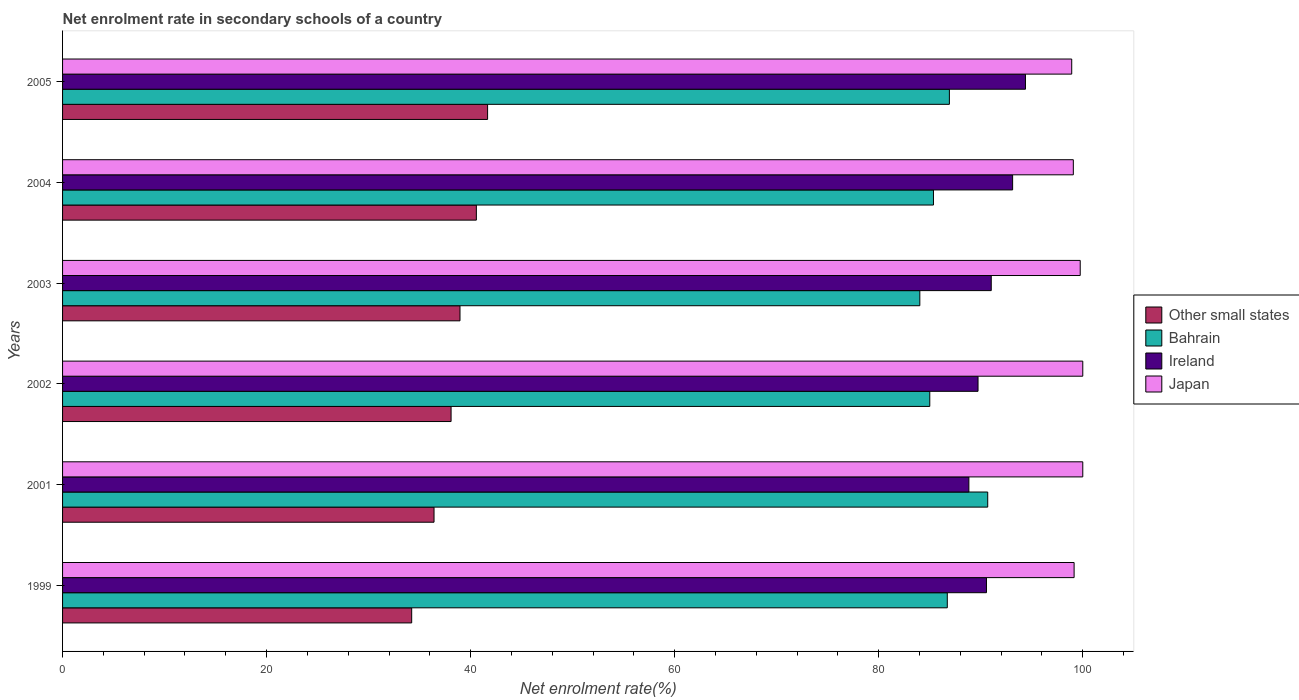How many groups of bars are there?
Your response must be concise. 6. How many bars are there on the 2nd tick from the top?
Make the answer very short. 4. How many bars are there on the 2nd tick from the bottom?
Give a very brief answer. 4. What is the label of the 1st group of bars from the top?
Ensure brevity in your answer.  2005. What is the net enrolment rate in secondary schools in Bahrain in 2004?
Make the answer very short. 85.36. Across all years, what is the minimum net enrolment rate in secondary schools in Ireland?
Give a very brief answer. 88.83. In which year was the net enrolment rate in secondary schools in Ireland maximum?
Your answer should be compact. 2005. What is the total net enrolment rate in secondary schools in Bahrain in the graph?
Keep it short and to the point. 518.72. What is the difference between the net enrolment rate in secondary schools in Ireland in 2001 and that in 2005?
Keep it short and to the point. -5.55. What is the difference between the net enrolment rate in secondary schools in Bahrain in 2005 and the net enrolment rate in secondary schools in Ireland in 2001?
Offer a very short reply. -1.91. What is the average net enrolment rate in secondary schools in Ireland per year?
Provide a succinct answer. 91.28. In the year 2004, what is the difference between the net enrolment rate in secondary schools in Other small states and net enrolment rate in secondary schools in Japan?
Provide a succinct answer. -58.51. What is the ratio of the net enrolment rate in secondary schools in Other small states in 2001 to that in 2002?
Keep it short and to the point. 0.96. Is the net enrolment rate in secondary schools in Japan in 2001 less than that in 2002?
Make the answer very short. No. Is the difference between the net enrolment rate in secondary schools in Other small states in 2004 and 2005 greater than the difference between the net enrolment rate in secondary schools in Japan in 2004 and 2005?
Give a very brief answer. No. What is the difference between the highest and the second highest net enrolment rate in secondary schools in Other small states?
Offer a very short reply. 1.1. What is the difference between the highest and the lowest net enrolment rate in secondary schools in Japan?
Your response must be concise. 1.08. Is the sum of the net enrolment rate in secondary schools in Bahrain in 2002 and 2003 greater than the maximum net enrolment rate in secondary schools in Japan across all years?
Offer a very short reply. Yes. What does the 2nd bar from the top in 2002 represents?
Make the answer very short. Ireland. What does the 3rd bar from the bottom in 2005 represents?
Keep it short and to the point. Ireland. Is it the case that in every year, the sum of the net enrolment rate in secondary schools in Other small states and net enrolment rate in secondary schools in Ireland is greater than the net enrolment rate in secondary schools in Japan?
Make the answer very short. Yes. Are all the bars in the graph horizontal?
Offer a terse response. Yes. How many years are there in the graph?
Make the answer very short. 6. How are the legend labels stacked?
Keep it short and to the point. Vertical. What is the title of the graph?
Your answer should be very brief. Net enrolment rate in secondary schools of a country. What is the label or title of the X-axis?
Your response must be concise. Net enrolment rate(%). What is the Net enrolment rate(%) in Other small states in 1999?
Your answer should be compact. 34.22. What is the Net enrolment rate(%) of Bahrain in 1999?
Offer a very short reply. 86.72. What is the Net enrolment rate(%) in Ireland in 1999?
Your answer should be very brief. 90.56. What is the Net enrolment rate(%) of Japan in 1999?
Offer a very short reply. 99.15. What is the Net enrolment rate(%) in Other small states in 2001?
Offer a very short reply. 36.41. What is the Net enrolment rate(%) of Bahrain in 2001?
Make the answer very short. 90.68. What is the Net enrolment rate(%) of Ireland in 2001?
Provide a succinct answer. 88.83. What is the Net enrolment rate(%) in Japan in 2001?
Your answer should be very brief. 100. What is the Net enrolment rate(%) of Other small states in 2002?
Your response must be concise. 38.08. What is the Net enrolment rate(%) of Bahrain in 2002?
Your answer should be compact. 85. What is the Net enrolment rate(%) of Ireland in 2002?
Provide a short and direct response. 89.73. What is the Net enrolment rate(%) of Japan in 2002?
Provide a short and direct response. 100. What is the Net enrolment rate(%) in Other small states in 2003?
Provide a succinct answer. 38.96. What is the Net enrolment rate(%) of Bahrain in 2003?
Your answer should be compact. 84.03. What is the Net enrolment rate(%) in Ireland in 2003?
Give a very brief answer. 91.03. What is the Net enrolment rate(%) in Japan in 2003?
Offer a very short reply. 99.75. What is the Net enrolment rate(%) of Other small states in 2004?
Your answer should be very brief. 40.56. What is the Net enrolment rate(%) of Bahrain in 2004?
Offer a very short reply. 85.36. What is the Net enrolment rate(%) of Ireland in 2004?
Make the answer very short. 93.12. What is the Net enrolment rate(%) in Japan in 2004?
Make the answer very short. 99.07. What is the Net enrolment rate(%) in Other small states in 2005?
Give a very brief answer. 41.66. What is the Net enrolment rate(%) of Bahrain in 2005?
Provide a succinct answer. 86.93. What is the Net enrolment rate(%) in Ireland in 2005?
Provide a succinct answer. 94.38. What is the Net enrolment rate(%) of Japan in 2005?
Your answer should be compact. 98.92. Across all years, what is the maximum Net enrolment rate(%) of Other small states?
Ensure brevity in your answer.  41.66. Across all years, what is the maximum Net enrolment rate(%) in Bahrain?
Provide a succinct answer. 90.68. Across all years, what is the maximum Net enrolment rate(%) in Ireland?
Make the answer very short. 94.38. Across all years, what is the maximum Net enrolment rate(%) of Japan?
Offer a very short reply. 100. Across all years, what is the minimum Net enrolment rate(%) of Other small states?
Make the answer very short. 34.22. Across all years, what is the minimum Net enrolment rate(%) of Bahrain?
Your response must be concise. 84.03. Across all years, what is the minimum Net enrolment rate(%) in Ireland?
Your response must be concise. 88.83. Across all years, what is the minimum Net enrolment rate(%) of Japan?
Offer a terse response. 98.92. What is the total Net enrolment rate(%) of Other small states in the graph?
Offer a very short reply. 229.89. What is the total Net enrolment rate(%) in Bahrain in the graph?
Provide a short and direct response. 518.72. What is the total Net enrolment rate(%) of Ireland in the graph?
Provide a succinct answer. 547.66. What is the total Net enrolment rate(%) of Japan in the graph?
Offer a terse response. 596.89. What is the difference between the Net enrolment rate(%) of Other small states in 1999 and that in 2001?
Provide a short and direct response. -2.19. What is the difference between the Net enrolment rate(%) of Bahrain in 1999 and that in 2001?
Your response must be concise. -3.96. What is the difference between the Net enrolment rate(%) of Ireland in 1999 and that in 2001?
Your answer should be very brief. 1.73. What is the difference between the Net enrolment rate(%) of Japan in 1999 and that in 2001?
Your response must be concise. -0.85. What is the difference between the Net enrolment rate(%) in Other small states in 1999 and that in 2002?
Provide a short and direct response. -3.86. What is the difference between the Net enrolment rate(%) in Bahrain in 1999 and that in 2002?
Ensure brevity in your answer.  1.72. What is the difference between the Net enrolment rate(%) of Ireland in 1999 and that in 2002?
Your answer should be compact. 0.83. What is the difference between the Net enrolment rate(%) in Japan in 1999 and that in 2002?
Give a very brief answer. -0.85. What is the difference between the Net enrolment rate(%) in Other small states in 1999 and that in 2003?
Offer a terse response. -4.74. What is the difference between the Net enrolment rate(%) of Bahrain in 1999 and that in 2003?
Offer a very short reply. 2.69. What is the difference between the Net enrolment rate(%) in Ireland in 1999 and that in 2003?
Provide a short and direct response. -0.47. What is the difference between the Net enrolment rate(%) of Japan in 1999 and that in 2003?
Your response must be concise. -0.6. What is the difference between the Net enrolment rate(%) in Other small states in 1999 and that in 2004?
Provide a short and direct response. -6.34. What is the difference between the Net enrolment rate(%) of Bahrain in 1999 and that in 2004?
Give a very brief answer. 1.36. What is the difference between the Net enrolment rate(%) in Ireland in 1999 and that in 2004?
Offer a terse response. -2.56. What is the difference between the Net enrolment rate(%) of Japan in 1999 and that in 2004?
Provide a succinct answer. 0.08. What is the difference between the Net enrolment rate(%) of Other small states in 1999 and that in 2005?
Provide a short and direct response. -7.44. What is the difference between the Net enrolment rate(%) of Bahrain in 1999 and that in 2005?
Offer a terse response. -0.2. What is the difference between the Net enrolment rate(%) of Ireland in 1999 and that in 2005?
Offer a very short reply. -3.82. What is the difference between the Net enrolment rate(%) of Japan in 1999 and that in 2005?
Offer a very short reply. 0.23. What is the difference between the Net enrolment rate(%) of Other small states in 2001 and that in 2002?
Your answer should be very brief. -1.67. What is the difference between the Net enrolment rate(%) in Bahrain in 2001 and that in 2002?
Keep it short and to the point. 5.68. What is the difference between the Net enrolment rate(%) of Ireland in 2001 and that in 2002?
Your response must be concise. -0.9. What is the difference between the Net enrolment rate(%) in Other small states in 2001 and that in 2003?
Provide a short and direct response. -2.54. What is the difference between the Net enrolment rate(%) in Bahrain in 2001 and that in 2003?
Offer a very short reply. 6.66. What is the difference between the Net enrolment rate(%) in Ireland in 2001 and that in 2003?
Provide a succinct answer. -2.19. What is the difference between the Net enrolment rate(%) in Japan in 2001 and that in 2003?
Offer a very short reply. 0.25. What is the difference between the Net enrolment rate(%) in Other small states in 2001 and that in 2004?
Give a very brief answer. -4.15. What is the difference between the Net enrolment rate(%) of Bahrain in 2001 and that in 2004?
Give a very brief answer. 5.32. What is the difference between the Net enrolment rate(%) in Ireland in 2001 and that in 2004?
Make the answer very short. -4.29. What is the difference between the Net enrolment rate(%) in Japan in 2001 and that in 2004?
Offer a very short reply. 0.93. What is the difference between the Net enrolment rate(%) of Other small states in 2001 and that in 2005?
Your answer should be very brief. -5.25. What is the difference between the Net enrolment rate(%) of Bahrain in 2001 and that in 2005?
Provide a succinct answer. 3.76. What is the difference between the Net enrolment rate(%) in Ireland in 2001 and that in 2005?
Make the answer very short. -5.55. What is the difference between the Net enrolment rate(%) in Japan in 2001 and that in 2005?
Provide a short and direct response. 1.08. What is the difference between the Net enrolment rate(%) in Other small states in 2002 and that in 2003?
Offer a very short reply. -0.87. What is the difference between the Net enrolment rate(%) in Bahrain in 2002 and that in 2003?
Make the answer very short. 0.98. What is the difference between the Net enrolment rate(%) of Ireland in 2002 and that in 2003?
Ensure brevity in your answer.  -1.29. What is the difference between the Net enrolment rate(%) in Japan in 2002 and that in 2003?
Your answer should be compact. 0.25. What is the difference between the Net enrolment rate(%) in Other small states in 2002 and that in 2004?
Provide a succinct answer. -2.48. What is the difference between the Net enrolment rate(%) in Bahrain in 2002 and that in 2004?
Keep it short and to the point. -0.36. What is the difference between the Net enrolment rate(%) of Ireland in 2002 and that in 2004?
Keep it short and to the point. -3.39. What is the difference between the Net enrolment rate(%) in Japan in 2002 and that in 2004?
Your answer should be compact. 0.93. What is the difference between the Net enrolment rate(%) in Other small states in 2002 and that in 2005?
Give a very brief answer. -3.58. What is the difference between the Net enrolment rate(%) in Bahrain in 2002 and that in 2005?
Keep it short and to the point. -1.92. What is the difference between the Net enrolment rate(%) in Ireland in 2002 and that in 2005?
Offer a terse response. -4.65. What is the difference between the Net enrolment rate(%) of Japan in 2002 and that in 2005?
Your response must be concise. 1.08. What is the difference between the Net enrolment rate(%) of Other small states in 2003 and that in 2004?
Offer a terse response. -1.6. What is the difference between the Net enrolment rate(%) of Bahrain in 2003 and that in 2004?
Offer a very short reply. -1.34. What is the difference between the Net enrolment rate(%) in Ireland in 2003 and that in 2004?
Ensure brevity in your answer.  -2.1. What is the difference between the Net enrolment rate(%) in Japan in 2003 and that in 2004?
Provide a succinct answer. 0.68. What is the difference between the Net enrolment rate(%) in Other small states in 2003 and that in 2005?
Offer a terse response. -2.7. What is the difference between the Net enrolment rate(%) in Bahrain in 2003 and that in 2005?
Make the answer very short. -2.9. What is the difference between the Net enrolment rate(%) in Ireland in 2003 and that in 2005?
Keep it short and to the point. -3.35. What is the difference between the Net enrolment rate(%) in Japan in 2003 and that in 2005?
Your answer should be compact. 0.83. What is the difference between the Net enrolment rate(%) in Other small states in 2004 and that in 2005?
Give a very brief answer. -1.1. What is the difference between the Net enrolment rate(%) of Bahrain in 2004 and that in 2005?
Your answer should be compact. -1.56. What is the difference between the Net enrolment rate(%) of Ireland in 2004 and that in 2005?
Your response must be concise. -1.26. What is the difference between the Net enrolment rate(%) in Japan in 2004 and that in 2005?
Provide a succinct answer. 0.16. What is the difference between the Net enrolment rate(%) in Other small states in 1999 and the Net enrolment rate(%) in Bahrain in 2001?
Your response must be concise. -56.46. What is the difference between the Net enrolment rate(%) of Other small states in 1999 and the Net enrolment rate(%) of Ireland in 2001?
Offer a very short reply. -54.61. What is the difference between the Net enrolment rate(%) in Other small states in 1999 and the Net enrolment rate(%) in Japan in 2001?
Provide a succinct answer. -65.78. What is the difference between the Net enrolment rate(%) in Bahrain in 1999 and the Net enrolment rate(%) in Ireland in 2001?
Your answer should be compact. -2.11. What is the difference between the Net enrolment rate(%) in Bahrain in 1999 and the Net enrolment rate(%) in Japan in 2001?
Offer a terse response. -13.28. What is the difference between the Net enrolment rate(%) in Ireland in 1999 and the Net enrolment rate(%) in Japan in 2001?
Ensure brevity in your answer.  -9.44. What is the difference between the Net enrolment rate(%) in Other small states in 1999 and the Net enrolment rate(%) in Bahrain in 2002?
Offer a very short reply. -50.78. What is the difference between the Net enrolment rate(%) in Other small states in 1999 and the Net enrolment rate(%) in Ireland in 2002?
Ensure brevity in your answer.  -55.51. What is the difference between the Net enrolment rate(%) in Other small states in 1999 and the Net enrolment rate(%) in Japan in 2002?
Provide a short and direct response. -65.78. What is the difference between the Net enrolment rate(%) of Bahrain in 1999 and the Net enrolment rate(%) of Ireland in 2002?
Keep it short and to the point. -3.01. What is the difference between the Net enrolment rate(%) in Bahrain in 1999 and the Net enrolment rate(%) in Japan in 2002?
Provide a succinct answer. -13.28. What is the difference between the Net enrolment rate(%) in Ireland in 1999 and the Net enrolment rate(%) in Japan in 2002?
Give a very brief answer. -9.44. What is the difference between the Net enrolment rate(%) in Other small states in 1999 and the Net enrolment rate(%) in Bahrain in 2003?
Give a very brief answer. -49.81. What is the difference between the Net enrolment rate(%) of Other small states in 1999 and the Net enrolment rate(%) of Ireland in 2003?
Offer a terse response. -56.81. What is the difference between the Net enrolment rate(%) of Other small states in 1999 and the Net enrolment rate(%) of Japan in 2003?
Provide a short and direct response. -65.53. What is the difference between the Net enrolment rate(%) in Bahrain in 1999 and the Net enrolment rate(%) in Ireland in 2003?
Make the answer very short. -4.31. What is the difference between the Net enrolment rate(%) of Bahrain in 1999 and the Net enrolment rate(%) of Japan in 2003?
Give a very brief answer. -13.03. What is the difference between the Net enrolment rate(%) in Ireland in 1999 and the Net enrolment rate(%) in Japan in 2003?
Offer a very short reply. -9.19. What is the difference between the Net enrolment rate(%) of Other small states in 1999 and the Net enrolment rate(%) of Bahrain in 2004?
Make the answer very short. -51.14. What is the difference between the Net enrolment rate(%) of Other small states in 1999 and the Net enrolment rate(%) of Ireland in 2004?
Your answer should be very brief. -58.9. What is the difference between the Net enrolment rate(%) in Other small states in 1999 and the Net enrolment rate(%) in Japan in 2004?
Your answer should be very brief. -64.85. What is the difference between the Net enrolment rate(%) in Bahrain in 1999 and the Net enrolment rate(%) in Ireland in 2004?
Your answer should be very brief. -6.4. What is the difference between the Net enrolment rate(%) of Bahrain in 1999 and the Net enrolment rate(%) of Japan in 2004?
Offer a terse response. -12.35. What is the difference between the Net enrolment rate(%) of Ireland in 1999 and the Net enrolment rate(%) of Japan in 2004?
Your response must be concise. -8.51. What is the difference between the Net enrolment rate(%) in Other small states in 1999 and the Net enrolment rate(%) in Bahrain in 2005?
Provide a short and direct response. -52.7. What is the difference between the Net enrolment rate(%) in Other small states in 1999 and the Net enrolment rate(%) in Ireland in 2005?
Give a very brief answer. -60.16. What is the difference between the Net enrolment rate(%) of Other small states in 1999 and the Net enrolment rate(%) of Japan in 2005?
Offer a terse response. -64.69. What is the difference between the Net enrolment rate(%) of Bahrain in 1999 and the Net enrolment rate(%) of Ireland in 2005?
Your answer should be compact. -7.66. What is the difference between the Net enrolment rate(%) in Bahrain in 1999 and the Net enrolment rate(%) in Japan in 2005?
Your answer should be compact. -12.19. What is the difference between the Net enrolment rate(%) in Ireland in 1999 and the Net enrolment rate(%) in Japan in 2005?
Give a very brief answer. -8.36. What is the difference between the Net enrolment rate(%) in Other small states in 2001 and the Net enrolment rate(%) in Bahrain in 2002?
Give a very brief answer. -48.59. What is the difference between the Net enrolment rate(%) in Other small states in 2001 and the Net enrolment rate(%) in Ireland in 2002?
Offer a terse response. -53.32. What is the difference between the Net enrolment rate(%) in Other small states in 2001 and the Net enrolment rate(%) in Japan in 2002?
Make the answer very short. -63.59. What is the difference between the Net enrolment rate(%) in Bahrain in 2001 and the Net enrolment rate(%) in Ireland in 2002?
Your answer should be very brief. 0.95. What is the difference between the Net enrolment rate(%) in Bahrain in 2001 and the Net enrolment rate(%) in Japan in 2002?
Provide a succinct answer. -9.32. What is the difference between the Net enrolment rate(%) in Ireland in 2001 and the Net enrolment rate(%) in Japan in 2002?
Give a very brief answer. -11.17. What is the difference between the Net enrolment rate(%) of Other small states in 2001 and the Net enrolment rate(%) of Bahrain in 2003?
Your response must be concise. -47.62. What is the difference between the Net enrolment rate(%) in Other small states in 2001 and the Net enrolment rate(%) in Ireland in 2003?
Your answer should be compact. -54.62. What is the difference between the Net enrolment rate(%) in Other small states in 2001 and the Net enrolment rate(%) in Japan in 2003?
Make the answer very short. -63.34. What is the difference between the Net enrolment rate(%) of Bahrain in 2001 and the Net enrolment rate(%) of Ireland in 2003?
Your answer should be very brief. -0.35. What is the difference between the Net enrolment rate(%) in Bahrain in 2001 and the Net enrolment rate(%) in Japan in 2003?
Ensure brevity in your answer.  -9.07. What is the difference between the Net enrolment rate(%) of Ireland in 2001 and the Net enrolment rate(%) of Japan in 2003?
Your answer should be compact. -10.91. What is the difference between the Net enrolment rate(%) of Other small states in 2001 and the Net enrolment rate(%) of Bahrain in 2004?
Make the answer very short. -48.95. What is the difference between the Net enrolment rate(%) of Other small states in 2001 and the Net enrolment rate(%) of Ireland in 2004?
Your response must be concise. -56.71. What is the difference between the Net enrolment rate(%) of Other small states in 2001 and the Net enrolment rate(%) of Japan in 2004?
Keep it short and to the point. -62.66. What is the difference between the Net enrolment rate(%) in Bahrain in 2001 and the Net enrolment rate(%) in Ireland in 2004?
Offer a very short reply. -2.44. What is the difference between the Net enrolment rate(%) of Bahrain in 2001 and the Net enrolment rate(%) of Japan in 2004?
Make the answer very short. -8.39. What is the difference between the Net enrolment rate(%) of Ireland in 2001 and the Net enrolment rate(%) of Japan in 2004?
Make the answer very short. -10.24. What is the difference between the Net enrolment rate(%) of Other small states in 2001 and the Net enrolment rate(%) of Bahrain in 2005?
Offer a very short reply. -50.51. What is the difference between the Net enrolment rate(%) in Other small states in 2001 and the Net enrolment rate(%) in Ireland in 2005?
Give a very brief answer. -57.97. What is the difference between the Net enrolment rate(%) in Other small states in 2001 and the Net enrolment rate(%) in Japan in 2005?
Offer a terse response. -62.5. What is the difference between the Net enrolment rate(%) in Bahrain in 2001 and the Net enrolment rate(%) in Ireland in 2005?
Make the answer very short. -3.7. What is the difference between the Net enrolment rate(%) of Bahrain in 2001 and the Net enrolment rate(%) of Japan in 2005?
Make the answer very short. -8.23. What is the difference between the Net enrolment rate(%) of Ireland in 2001 and the Net enrolment rate(%) of Japan in 2005?
Provide a short and direct response. -10.08. What is the difference between the Net enrolment rate(%) of Other small states in 2002 and the Net enrolment rate(%) of Bahrain in 2003?
Offer a very short reply. -45.95. What is the difference between the Net enrolment rate(%) of Other small states in 2002 and the Net enrolment rate(%) of Ireland in 2003?
Ensure brevity in your answer.  -52.95. What is the difference between the Net enrolment rate(%) of Other small states in 2002 and the Net enrolment rate(%) of Japan in 2003?
Provide a succinct answer. -61.67. What is the difference between the Net enrolment rate(%) of Bahrain in 2002 and the Net enrolment rate(%) of Ireland in 2003?
Your answer should be compact. -6.03. What is the difference between the Net enrolment rate(%) in Bahrain in 2002 and the Net enrolment rate(%) in Japan in 2003?
Ensure brevity in your answer.  -14.75. What is the difference between the Net enrolment rate(%) of Ireland in 2002 and the Net enrolment rate(%) of Japan in 2003?
Give a very brief answer. -10.02. What is the difference between the Net enrolment rate(%) in Other small states in 2002 and the Net enrolment rate(%) in Bahrain in 2004?
Ensure brevity in your answer.  -47.28. What is the difference between the Net enrolment rate(%) in Other small states in 2002 and the Net enrolment rate(%) in Ireland in 2004?
Offer a very short reply. -55.04. What is the difference between the Net enrolment rate(%) of Other small states in 2002 and the Net enrolment rate(%) of Japan in 2004?
Keep it short and to the point. -60.99. What is the difference between the Net enrolment rate(%) in Bahrain in 2002 and the Net enrolment rate(%) in Ireland in 2004?
Keep it short and to the point. -8.12. What is the difference between the Net enrolment rate(%) of Bahrain in 2002 and the Net enrolment rate(%) of Japan in 2004?
Ensure brevity in your answer.  -14.07. What is the difference between the Net enrolment rate(%) of Ireland in 2002 and the Net enrolment rate(%) of Japan in 2004?
Your response must be concise. -9.34. What is the difference between the Net enrolment rate(%) in Other small states in 2002 and the Net enrolment rate(%) in Bahrain in 2005?
Provide a succinct answer. -48.84. What is the difference between the Net enrolment rate(%) in Other small states in 2002 and the Net enrolment rate(%) in Ireland in 2005?
Keep it short and to the point. -56.3. What is the difference between the Net enrolment rate(%) of Other small states in 2002 and the Net enrolment rate(%) of Japan in 2005?
Provide a succinct answer. -60.83. What is the difference between the Net enrolment rate(%) of Bahrain in 2002 and the Net enrolment rate(%) of Ireland in 2005?
Give a very brief answer. -9.38. What is the difference between the Net enrolment rate(%) in Bahrain in 2002 and the Net enrolment rate(%) in Japan in 2005?
Ensure brevity in your answer.  -13.91. What is the difference between the Net enrolment rate(%) in Ireland in 2002 and the Net enrolment rate(%) in Japan in 2005?
Your answer should be compact. -9.18. What is the difference between the Net enrolment rate(%) of Other small states in 2003 and the Net enrolment rate(%) of Bahrain in 2004?
Offer a terse response. -46.41. What is the difference between the Net enrolment rate(%) of Other small states in 2003 and the Net enrolment rate(%) of Ireland in 2004?
Your answer should be compact. -54.17. What is the difference between the Net enrolment rate(%) of Other small states in 2003 and the Net enrolment rate(%) of Japan in 2004?
Provide a succinct answer. -60.12. What is the difference between the Net enrolment rate(%) in Bahrain in 2003 and the Net enrolment rate(%) in Ireland in 2004?
Ensure brevity in your answer.  -9.1. What is the difference between the Net enrolment rate(%) in Bahrain in 2003 and the Net enrolment rate(%) in Japan in 2004?
Give a very brief answer. -15.05. What is the difference between the Net enrolment rate(%) in Ireland in 2003 and the Net enrolment rate(%) in Japan in 2004?
Your response must be concise. -8.05. What is the difference between the Net enrolment rate(%) of Other small states in 2003 and the Net enrolment rate(%) of Bahrain in 2005?
Provide a succinct answer. -47.97. What is the difference between the Net enrolment rate(%) of Other small states in 2003 and the Net enrolment rate(%) of Ireland in 2005?
Your response must be concise. -55.43. What is the difference between the Net enrolment rate(%) in Other small states in 2003 and the Net enrolment rate(%) in Japan in 2005?
Offer a terse response. -59.96. What is the difference between the Net enrolment rate(%) of Bahrain in 2003 and the Net enrolment rate(%) of Ireland in 2005?
Your answer should be compact. -10.36. What is the difference between the Net enrolment rate(%) of Bahrain in 2003 and the Net enrolment rate(%) of Japan in 2005?
Keep it short and to the point. -14.89. What is the difference between the Net enrolment rate(%) in Ireland in 2003 and the Net enrolment rate(%) in Japan in 2005?
Offer a terse response. -7.89. What is the difference between the Net enrolment rate(%) of Other small states in 2004 and the Net enrolment rate(%) of Bahrain in 2005?
Provide a succinct answer. -46.37. What is the difference between the Net enrolment rate(%) of Other small states in 2004 and the Net enrolment rate(%) of Ireland in 2005?
Offer a terse response. -53.82. What is the difference between the Net enrolment rate(%) of Other small states in 2004 and the Net enrolment rate(%) of Japan in 2005?
Offer a very short reply. -58.36. What is the difference between the Net enrolment rate(%) in Bahrain in 2004 and the Net enrolment rate(%) in Ireland in 2005?
Provide a short and direct response. -9.02. What is the difference between the Net enrolment rate(%) of Bahrain in 2004 and the Net enrolment rate(%) of Japan in 2005?
Offer a very short reply. -13.55. What is the difference between the Net enrolment rate(%) of Ireland in 2004 and the Net enrolment rate(%) of Japan in 2005?
Your response must be concise. -5.79. What is the average Net enrolment rate(%) of Other small states per year?
Make the answer very short. 38.31. What is the average Net enrolment rate(%) of Bahrain per year?
Your answer should be very brief. 86.45. What is the average Net enrolment rate(%) of Ireland per year?
Your answer should be very brief. 91.28. What is the average Net enrolment rate(%) in Japan per year?
Your answer should be compact. 99.48. In the year 1999, what is the difference between the Net enrolment rate(%) in Other small states and Net enrolment rate(%) in Bahrain?
Keep it short and to the point. -52.5. In the year 1999, what is the difference between the Net enrolment rate(%) in Other small states and Net enrolment rate(%) in Ireland?
Your response must be concise. -56.34. In the year 1999, what is the difference between the Net enrolment rate(%) in Other small states and Net enrolment rate(%) in Japan?
Keep it short and to the point. -64.93. In the year 1999, what is the difference between the Net enrolment rate(%) of Bahrain and Net enrolment rate(%) of Ireland?
Your answer should be compact. -3.84. In the year 1999, what is the difference between the Net enrolment rate(%) of Bahrain and Net enrolment rate(%) of Japan?
Your response must be concise. -12.43. In the year 1999, what is the difference between the Net enrolment rate(%) in Ireland and Net enrolment rate(%) in Japan?
Ensure brevity in your answer.  -8.59. In the year 2001, what is the difference between the Net enrolment rate(%) in Other small states and Net enrolment rate(%) in Bahrain?
Provide a succinct answer. -54.27. In the year 2001, what is the difference between the Net enrolment rate(%) of Other small states and Net enrolment rate(%) of Ireland?
Your answer should be very brief. -52.42. In the year 2001, what is the difference between the Net enrolment rate(%) of Other small states and Net enrolment rate(%) of Japan?
Offer a terse response. -63.59. In the year 2001, what is the difference between the Net enrolment rate(%) in Bahrain and Net enrolment rate(%) in Ireland?
Keep it short and to the point. 1.85. In the year 2001, what is the difference between the Net enrolment rate(%) of Bahrain and Net enrolment rate(%) of Japan?
Give a very brief answer. -9.32. In the year 2001, what is the difference between the Net enrolment rate(%) in Ireland and Net enrolment rate(%) in Japan?
Give a very brief answer. -11.17. In the year 2002, what is the difference between the Net enrolment rate(%) in Other small states and Net enrolment rate(%) in Bahrain?
Your response must be concise. -46.92. In the year 2002, what is the difference between the Net enrolment rate(%) of Other small states and Net enrolment rate(%) of Ireland?
Give a very brief answer. -51.65. In the year 2002, what is the difference between the Net enrolment rate(%) of Other small states and Net enrolment rate(%) of Japan?
Your response must be concise. -61.92. In the year 2002, what is the difference between the Net enrolment rate(%) in Bahrain and Net enrolment rate(%) in Ireland?
Offer a very short reply. -4.73. In the year 2002, what is the difference between the Net enrolment rate(%) in Bahrain and Net enrolment rate(%) in Japan?
Your response must be concise. -15. In the year 2002, what is the difference between the Net enrolment rate(%) in Ireland and Net enrolment rate(%) in Japan?
Give a very brief answer. -10.27. In the year 2003, what is the difference between the Net enrolment rate(%) of Other small states and Net enrolment rate(%) of Bahrain?
Provide a succinct answer. -45.07. In the year 2003, what is the difference between the Net enrolment rate(%) in Other small states and Net enrolment rate(%) in Ireland?
Give a very brief answer. -52.07. In the year 2003, what is the difference between the Net enrolment rate(%) of Other small states and Net enrolment rate(%) of Japan?
Keep it short and to the point. -60.79. In the year 2003, what is the difference between the Net enrolment rate(%) of Bahrain and Net enrolment rate(%) of Ireland?
Offer a very short reply. -7. In the year 2003, what is the difference between the Net enrolment rate(%) of Bahrain and Net enrolment rate(%) of Japan?
Offer a very short reply. -15.72. In the year 2003, what is the difference between the Net enrolment rate(%) in Ireland and Net enrolment rate(%) in Japan?
Your answer should be very brief. -8.72. In the year 2004, what is the difference between the Net enrolment rate(%) of Other small states and Net enrolment rate(%) of Bahrain?
Give a very brief answer. -44.8. In the year 2004, what is the difference between the Net enrolment rate(%) in Other small states and Net enrolment rate(%) in Ireland?
Your answer should be very brief. -52.56. In the year 2004, what is the difference between the Net enrolment rate(%) in Other small states and Net enrolment rate(%) in Japan?
Your answer should be very brief. -58.51. In the year 2004, what is the difference between the Net enrolment rate(%) in Bahrain and Net enrolment rate(%) in Ireland?
Your answer should be very brief. -7.76. In the year 2004, what is the difference between the Net enrolment rate(%) in Bahrain and Net enrolment rate(%) in Japan?
Give a very brief answer. -13.71. In the year 2004, what is the difference between the Net enrolment rate(%) of Ireland and Net enrolment rate(%) of Japan?
Your answer should be compact. -5.95. In the year 2005, what is the difference between the Net enrolment rate(%) in Other small states and Net enrolment rate(%) in Bahrain?
Provide a succinct answer. -45.27. In the year 2005, what is the difference between the Net enrolment rate(%) of Other small states and Net enrolment rate(%) of Ireland?
Provide a short and direct response. -52.72. In the year 2005, what is the difference between the Net enrolment rate(%) of Other small states and Net enrolment rate(%) of Japan?
Keep it short and to the point. -57.26. In the year 2005, what is the difference between the Net enrolment rate(%) of Bahrain and Net enrolment rate(%) of Ireland?
Your answer should be compact. -7.46. In the year 2005, what is the difference between the Net enrolment rate(%) in Bahrain and Net enrolment rate(%) in Japan?
Your answer should be compact. -11.99. In the year 2005, what is the difference between the Net enrolment rate(%) of Ireland and Net enrolment rate(%) of Japan?
Provide a succinct answer. -4.53. What is the ratio of the Net enrolment rate(%) in Other small states in 1999 to that in 2001?
Provide a short and direct response. 0.94. What is the ratio of the Net enrolment rate(%) of Bahrain in 1999 to that in 2001?
Provide a short and direct response. 0.96. What is the ratio of the Net enrolment rate(%) in Ireland in 1999 to that in 2001?
Provide a short and direct response. 1.02. What is the ratio of the Net enrolment rate(%) in Other small states in 1999 to that in 2002?
Make the answer very short. 0.9. What is the ratio of the Net enrolment rate(%) of Bahrain in 1999 to that in 2002?
Ensure brevity in your answer.  1.02. What is the ratio of the Net enrolment rate(%) in Ireland in 1999 to that in 2002?
Offer a terse response. 1.01. What is the ratio of the Net enrolment rate(%) of Other small states in 1999 to that in 2003?
Make the answer very short. 0.88. What is the ratio of the Net enrolment rate(%) of Bahrain in 1999 to that in 2003?
Keep it short and to the point. 1.03. What is the ratio of the Net enrolment rate(%) in Ireland in 1999 to that in 2003?
Your answer should be compact. 0.99. What is the ratio of the Net enrolment rate(%) of Japan in 1999 to that in 2003?
Offer a terse response. 0.99. What is the ratio of the Net enrolment rate(%) of Other small states in 1999 to that in 2004?
Your answer should be compact. 0.84. What is the ratio of the Net enrolment rate(%) in Bahrain in 1999 to that in 2004?
Your answer should be very brief. 1.02. What is the ratio of the Net enrolment rate(%) of Ireland in 1999 to that in 2004?
Provide a succinct answer. 0.97. What is the ratio of the Net enrolment rate(%) in Other small states in 1999 to that in 2005?
Offer a very short reply. 0.82. What is the ratio of the Net enrolment rate(%) in Bahrain in 1999 to that in 2005?
Your answer should be compact. 1. What is the ratio of the Net enrolment rate(%) of Ireland in 1999 to that in 2005?
Keep it short and to the point. 0.96. What is the ratio of the Net enrolment rate(%) in Japan in 1999 to that in 2005?
Offer a terse response. 1. What is the ratio of the Net enrolment rate(%) in Other small states in 2001 to that in 2002?
Your answer should be compact. 0.96. What is the ratio of the Net enrolment rate(%) in Bahrain in 2001 to that in 2002?
Ensure brevity in your answer.  1.07. What is the ratio of the Net enrolment rate(%) in Ireland in 2001 to that in 2002?
Your answer should be very brief. 0.99. What is the ratio of the Net enrolment rate(%) of Japan in 2001 to that in 2002?
Your response must be concise. 1. What is the ratio of the Net enrolment rate(%) of Other small states in 2001 to that in 2003?
Ensure brevity in your answer.  0.93. What is the ratio of the Net enrolment rate(%) in Bahrain in 2001 to that in 2003?
Offer a very short reply. 1.08. What is the ratio of the Net enrolment rate(%) in Ireland in 2001 to that in 2003?
Your response must be concise. 0.98. What is the ratio of the Net enrolment rate(%) of Other small states in 2001 to that in 2004?
Give a very brief answer. 0.9. What is the ratio of the Net enrolment rate(%) in Bahrain in 2001 to that in 2004?
Make the answer very short. 1.06. What is the ratio of the Net enrolment rate(%) in Ireland in 2001 to that in 2004?
Ensure brevity in your answer.  0.95. What is the ratio of the Net enrolment rate(%) in Japan in 2001 to that in 2004?
Offer a very short reply. 1.01. What is the ratio of the Net enrolment rate(%) in Other small states in 2001 to that in 2005?
Give a very brief answer. 0.87. What is the ratio of the Net enrolment rate(%) of Bahrain in 2001 to that in 2005?
Keep it short and to the point. 1.04. What is the ratio of the Net enrolment rate(%) of Ireland in 2001 to that in 2005?
Provide a succinct answer. 0.94. What is the ratio of the Net enrolment rate(%) of Other small states in 2002 to that in 2003?
Ensure brevity in your answer.  0.98. What is the ratio of the Net enrolment rate(%) of Bahrain in 2002 to that in 2003?
Offer a terse response. 1.01. What is the ratio of the Net enrolment rate(%) of Ireland in 2002 to that in 2003?
Your answer should be very brief. 0.99. What is the ratio of the Net enrolment rate(%) in Japan in 2002 to that in 2003?
Offer a very short reply. 1. What is the ratio of the Net enrolment rate(%) in Other small states in 2002 to that in 2004?
Ensure brevity in your answer.  0.94. What is the ratio of the Net enrolment rate(%) in Ireland in 2002 to that in 2004?
Offer a very short reply. 0.96. What is the ratio of the Net enrolment rate(%) in Japan in 2002 to that in 2004?
Keep it short and to the point. 1.01. What is the ratio of the Net enrolment rate(%) of Other small states in 2002 to that in 2005?
Make the answer very short. 0.91. What is the ratio of the Net enrolment rate(%) of Bahrain in 2002 to that in 2005?
Offer a terse response. 0.98. What is the ratio of the Net enrolment rate(%) in Ireland in 2002 to that in 2005?
Your answer should be very brief. 0.95. What is the ratio of the Net enrolment rate(%) of Other small states in 2003 to that in 2004?
Offer a terse response. 0.96. What is the ratio of the Net enrolment rate(%) of Bahrain in 2003 to that in 2004?
Provide a succinct answer. 0.98. What is the ratio of the Net enrolment rate(%) of Ireland in 2003 to that in 2004?
Provide a succinct answer. 0.98. What is the ratio of the Net enrolment rate(%) of Japan in 2003 to that in 2004?
Make the answer very short. 1.01. What is the ratio of the Net enrolment rate(%) of Other small states in 2003 to that in 2005?
Provide a short and direct response. 0.94. What is the ratio of the Net enrolment rate(%) of Bahrain in 2003 to that in 2005?
Offer a very short reply. 0.97. What is the ratio of the Net enrolment rate(%) of Ireland in 2003 to that in 2005?
Keep it short and to the point. 0.96. What is the ratio of the Net enrolment rate(%) of Japan in 2003 to that in 2005?
Give a very brief answer. 1.01. What is the ratio of the Net enrolment rate(%) of Other small states in 2004 to that in 2005?
Keep it short and to the point. 0.97. What is the ratio of the Net enrolment rate(%) of Bahrain in 2004 to that in 2005?
Provide a short and direct response. 0.98. What is the ratio of the Net enrolment rate(%) of Ireland in 2004 to that in 2005?
Provide a short and direct response. 0.99. What is the ratio of the Net enrolment rate(%) in Japan in 2004 to that in 2005?
Ensure brevity in your answer.  1. What is the difference between the highest and the second highest Net enrolment rate(%) of Other small states?
Offer a very short reply. 1.1. What is the difference between the highest and the second highest Net enrolment rate(%) in Bahrain?
Provide a succinct answer. 3.76. What is the difference between the highest and the second highest Net enrolment rate(%) of Ireland?
Ensure brevity in your answer.  1.26. What is the difference between the highest and the lowest Net enrolment rate(%) of Other small states?
Provide a succinct answer. 7.44. What is the difference between the highest and the lowest Net enrolment rate(%) in Bahrain?
Your answer should be very brief. 6.66. What is the difference between the highest and the lowest Net enrolment rate(%) in Ireland?
Provide a succinct answer. 5.55. What is the difference between the highest and the lowest Net enrolment rate(%) of Japan?
Provide a succinct answer. 1.08. 